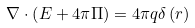Convert formula to latex. <formula><loc_0><loc_0><loc_500><loc_500>\nabla \cdot \left ( E + 4 \pi \Pi \right ) = 4 \pi q \delta \left ( r \right )</formula> 